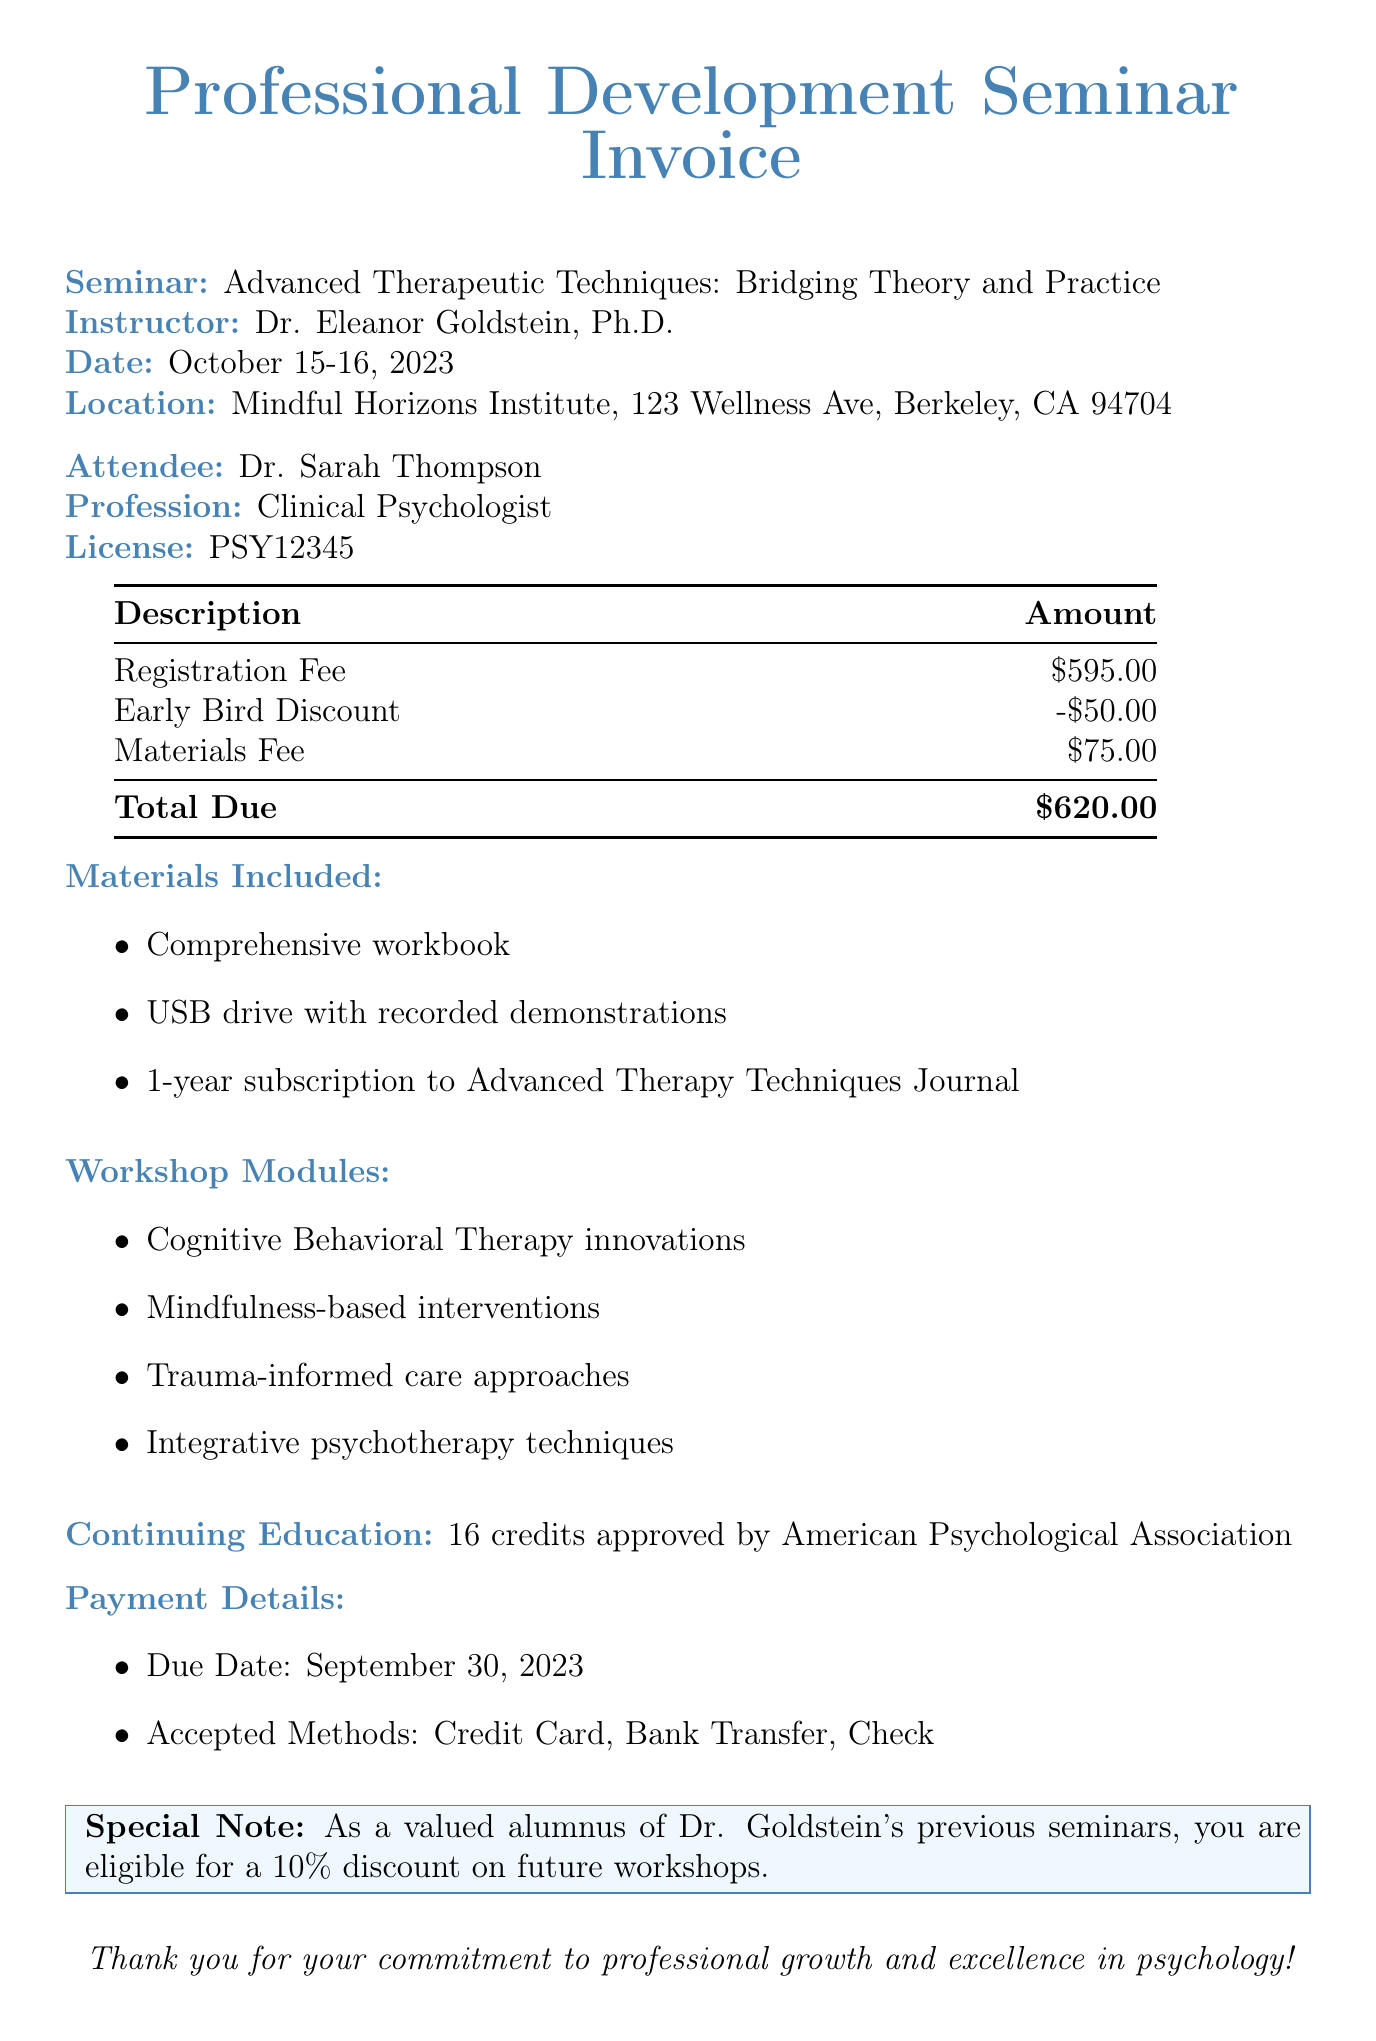What is the name of the seminar? The name of the seminar is provided in the header section of the document.
Answer: Advanced Therapeutic Techniques: Bridging Theory and Practice Who is the instructor of the seminar? The instructor's name is listed under the seminar details section.
Answer: Dr. Eleanor Goldstein, Ph.D What is the total amount due? The total amount due is specified at the bottom of the table.
Answer: $620.00 What was the early bird discount? The early bird discount is described as a deduction from the registration fee.
Answer: -$50.00 How many continuing education credits are approved? The number of credits is mentioned toward the end of the document.
Answer: 16 credits What materials are included in the registration? The materials included are itemized in the materials list section.
Answer: Comprehensive workbook, USB drive with recorded demonstrations, 1-year subscription to Advanced Therapy Techniques Journal What date is the payment due? The payment due date is clearly stated in the payment details section.
Answer: September 30, 2023 What payment methods are accepted? The accepted payment methods are listed under the payment details section.
Answer: Credit Card, Bank Transfer, Check What are the workshop modules focused on? The focus of the workshop modules is listed in a bullet-point format.
Answer: Cognitive Behavioral Therapy innovations, Mindfulness-based interventions, Trauma-informed care approaches, Integrative psychotherapy techniques 